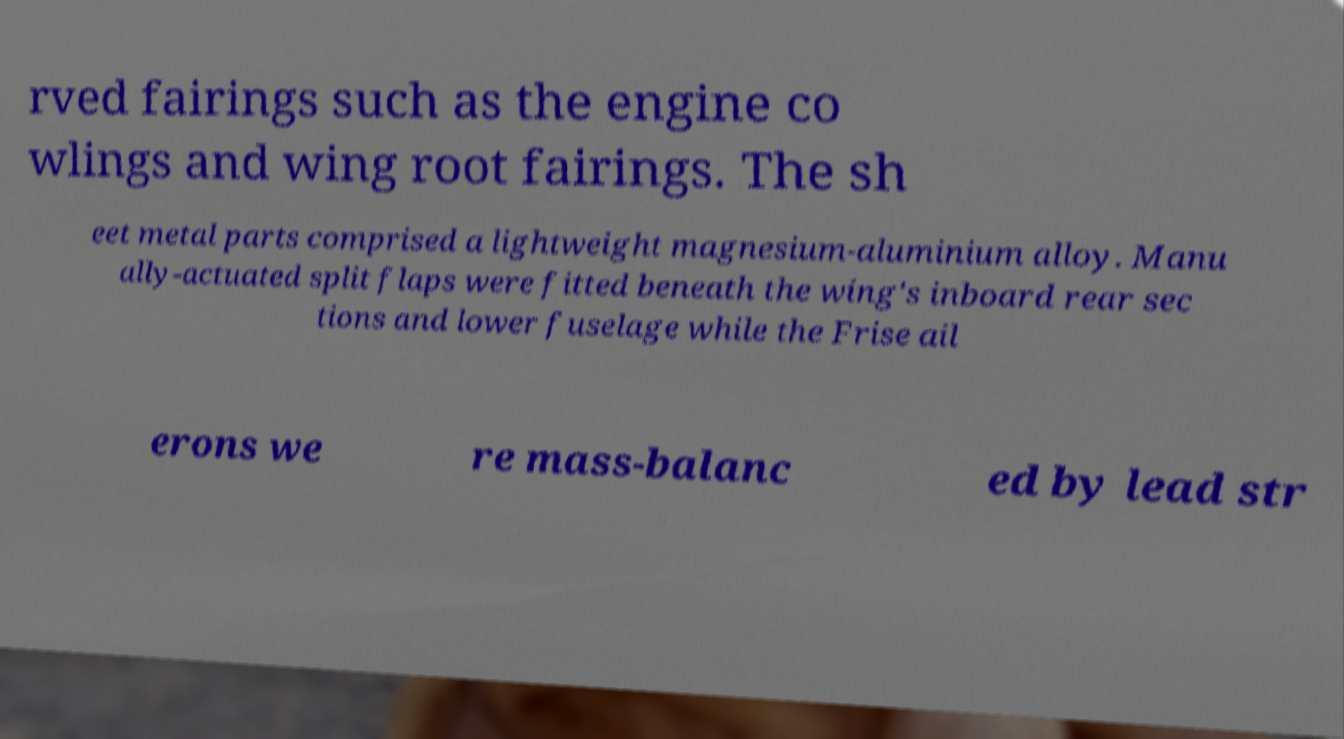Could you extract and type out the text from this image? rved fairings such as the engine co wlings and wing root fairings. The sh eet metal parts comprised a lightweight magnesium-aluminium alloy. Manu ally-actuated split flaps were fitted beneath the wing's inboard rear sec tions and lower fuselage while the Frise ail erons we re mass-balanc ed by lead str 